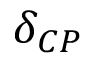<formula> <loc_0><loc_0><loc_500><loc_500>\delta _ { C P }</formula> 